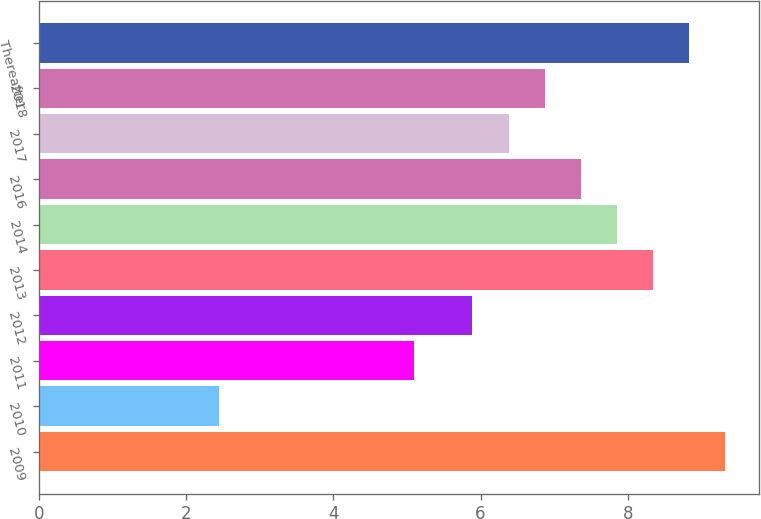Convert chart. <chart><loc_0><loc_0><loc_500><loc_500><bar_chart><fcel>2009<fcel>2010<fcel>2011<fcel>2012<fcel>2013<fcel>2014<fcel>2016<fcel>2017<fcel>2018<fcel>Thereafter<nl><fcel>9.32<fcel>2.45<fcel>5.09<fcel>5.89<fcel>8.34<fcel>7.85<fcel>7.36<fcel>6.38<fcel>6.87<fcel>8.83<nl></chart> 